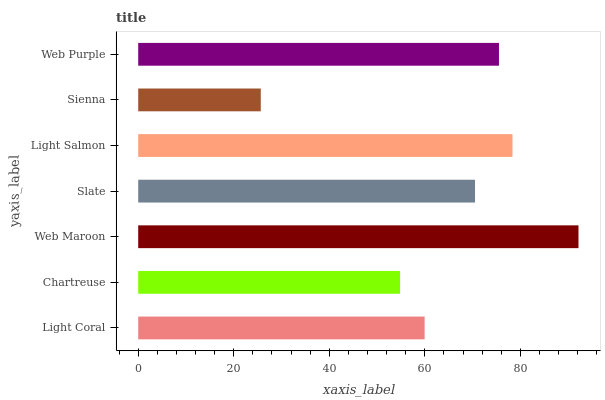Is Sienna the minimum?
Answer yes or no. Yes. Is Web Maroon the maximum?
Answer yes or no. Yes. Is Chartreuse the minimum?
Answer yes or no. No. Is Chartreuse the maximum?
Answer yes or no. No. Is Light Coral greater than Chartreuse?
Answer yes or no. Yes. Is Chartreuse less than Light Coral?
Answer yes or no. Yes. Is Chartreuse greater than Light Coral?
Answer yes or no. No. Is Light Coral less than Chartreuse?
Answer yes or no. No. Is Slate the high median?
Answer yes or no. Yes. Is Slate the low median?
Answer yes or no. Yes. Is Web Maroon the high median?
Answer yes or no. No. Is Web Maroon the low median?
Answer yes or no. No. 